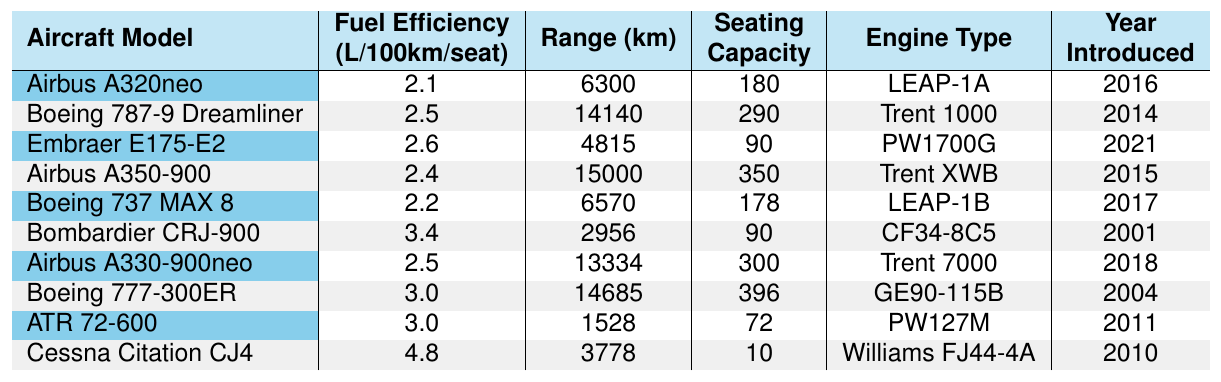What is the fuel efficiency of the Airbus A350-900? The table shows that the fuel efficiency of the Airbus A350-900 is listed as 2.4 L/100km/seat.
Answer: 2.4 L/100km/seat Which aircraft has the highest seating capacity? By examining the seating capacity column, the Boeing 777-300ER has the highest seating capacity at 396 seats.
Answer: 396 Which aircrafts were introduced after 2015? Looking at the year introduced column, the Embraer E175-E2 (2021) and Airbus A330-900neo (2018) were introduced after 2015.
Answer: Embraer E175-E2, Airbus A330-900neo What is the difference in fuel efficiency between the most and least efficient aircraft? The most efficient aircraft is the Airbus A320neo with 2.1 L/100km/seat, and the least efficient is the Cessna Citation CJ4 with 4.8 L/100km/seat. The difference is 4.8 - 2.1 = 2.7 L/100km/seat.
Answer: 2.7 L/100km/seat How many aircraft have a fuel efficiency of 3.0 L/100km/seat or less? The aircraft with 3.0 L/100km/seat or less are Airbus A320neo (2.1), Boeing 737 MAX 8 (2.2), Airbus A350-900 (2.4), Airbus A330-900neo (2.5), and ATR 72-600 (3.0), totaling 5 aircraft.
Answer: 5 Is it true that all aircraft introduced after 2015 have a fuel efficiency of at least 2.5 L/100km/seat? The Embraer E175-E2 was introduced in 2021 and has a fuel efficiency of 2.6, while the Airbus A330-900neo, introduced in 2018, has 2.5; thus, both have a fuel efficiency of at least 2.5 L/100km/seat. The statement is true.
Answer: Yes What is the average fuel efficiency of all the aircraft listed? To find the average, sum all fuel efficiencies: 2.1 + 2.5 + 2.6 + 2.4 + 2.2 + 3.4 + 2.5 + 3.0 + 3.0 + 4.8 = 26.5. There are 10 aircraft, so the average is 26.5 / 10 = 2.65 L/100km/seat.
Answer: 2.65 L/100km/seat How many aircraft have an engine type of 'Trent'? From the table, the Airbus A350-900, Boeing 787-9 Dreamliner, and Airbus A330-900neo have the engine type 'Trent', totaling 3 aircraft.
Answer: 3 Which two aircraft models have the same fuel efficiency? The Airbus A330-900neo and Boeing 787-9 Dreamliner both have a fuel efficiency of 2.5 L/100km/seat.
Answer: Airbus A330-900neo, Boeing 787-9 Dreamliner What percentage of aircraft have a fuel efficiency greater than 3.0 L/100km/seat? From the table, there are 3 aircraft with fuel efficiency greater than 3.0. There are 10 aircraft total, so the percentage is (3/10) * 100 = 30%.
Answer: 30% 